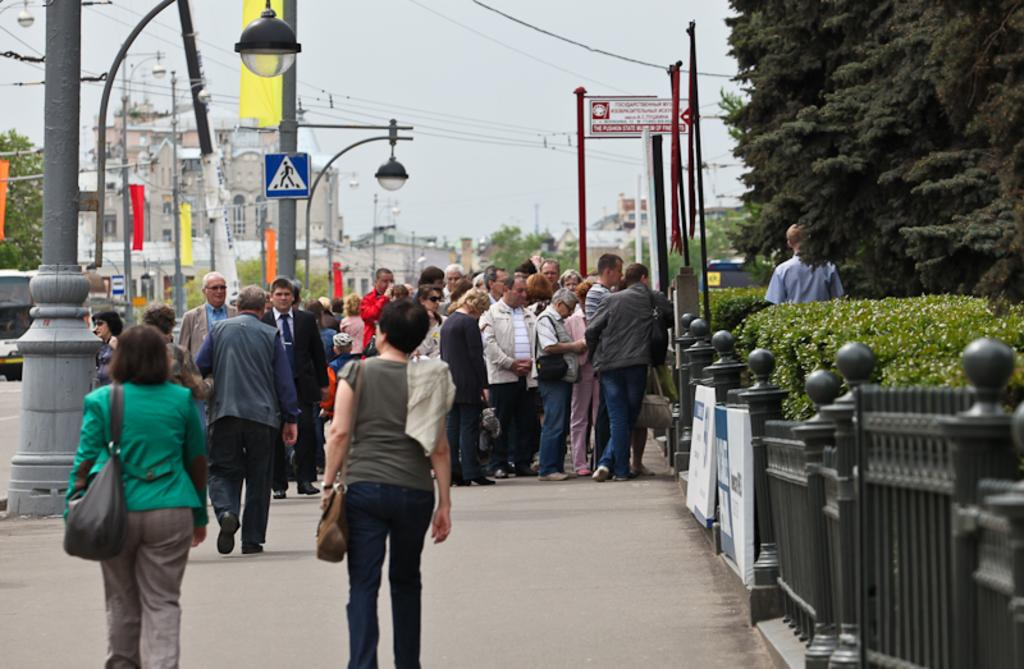How many people are in the image? There is a group of people in the image. What are some of the people in the image doing? Some people are standing, while three are walking on the road. What can be seen in the image besides the people? There are flags, trees, buildings, a fence, and the sky visible in the image. What type of tub can be seen in the image? There is no tub present in the image. What is the group of people using the yarn for in the image? There is no yarn present in the image, and therefore no such activity can be observed. 